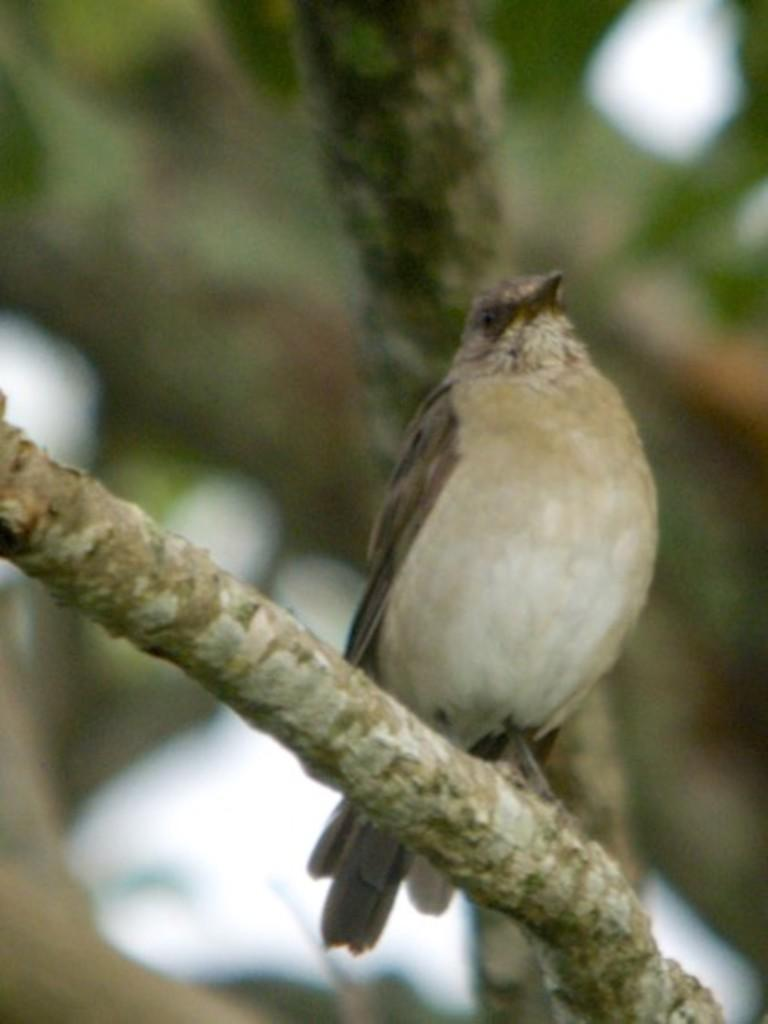What type of animal is in the image? There is a bird in the image. What colors can be seen on the bird? The bird has cream, brown, and black colors. Where is the bird located in the image? The bird is on the branch of a tree. Can you describe the background of the image? The background of the image is blurred. What type of crate is the actor holding in the image? There is no crate or actor present in the image; it features a bird on a tree branch. What type of bottle can be seen in the bird's beak in the image? There is no bottle present in the image; the bird is simply perched on a tree branch. 